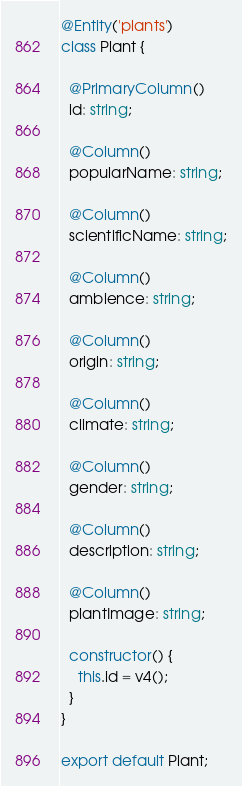<code> <loc_0><loc_0><loc_500><loc_500><_TypeScript_>@Entity('plants')
class Plant {

  @PrimaryColumn()
  id: string;

  @Column()
  popularName: string;

  @Column()
  scientificName: string;

  @Column()
  ambience: string;

  @Column()
  origin: string;

  @Column()
  climate: string;
  
  @Column()
  gender: string;

  @Column()
  description: string;

  @Column()
  plantImage: string;

  constructor() {
    this.id = v4();
  }
}

export default Plant;</code> 